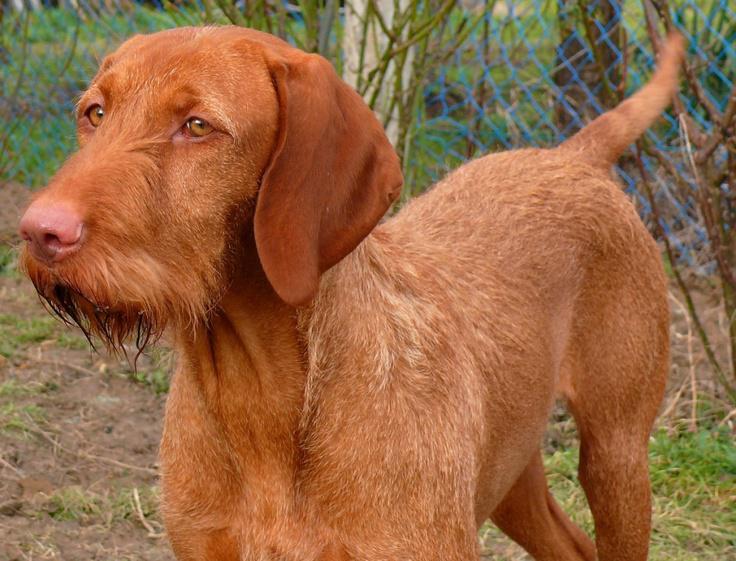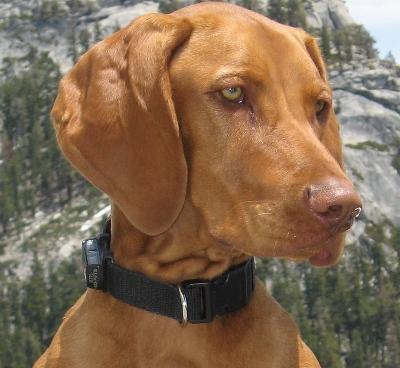The first image is the image on the left, the second image is the image on the right. For the images shown, is this caption "The dog in the right image is wearing a black collar." true? Answer yes or no. Yes. The first image is the image on the left, the second image is the image on the right. Assess this claim about the two images: "One dog is outdoors, while the other dog is indoors.". Correct or not? Answer yes or no. No. 